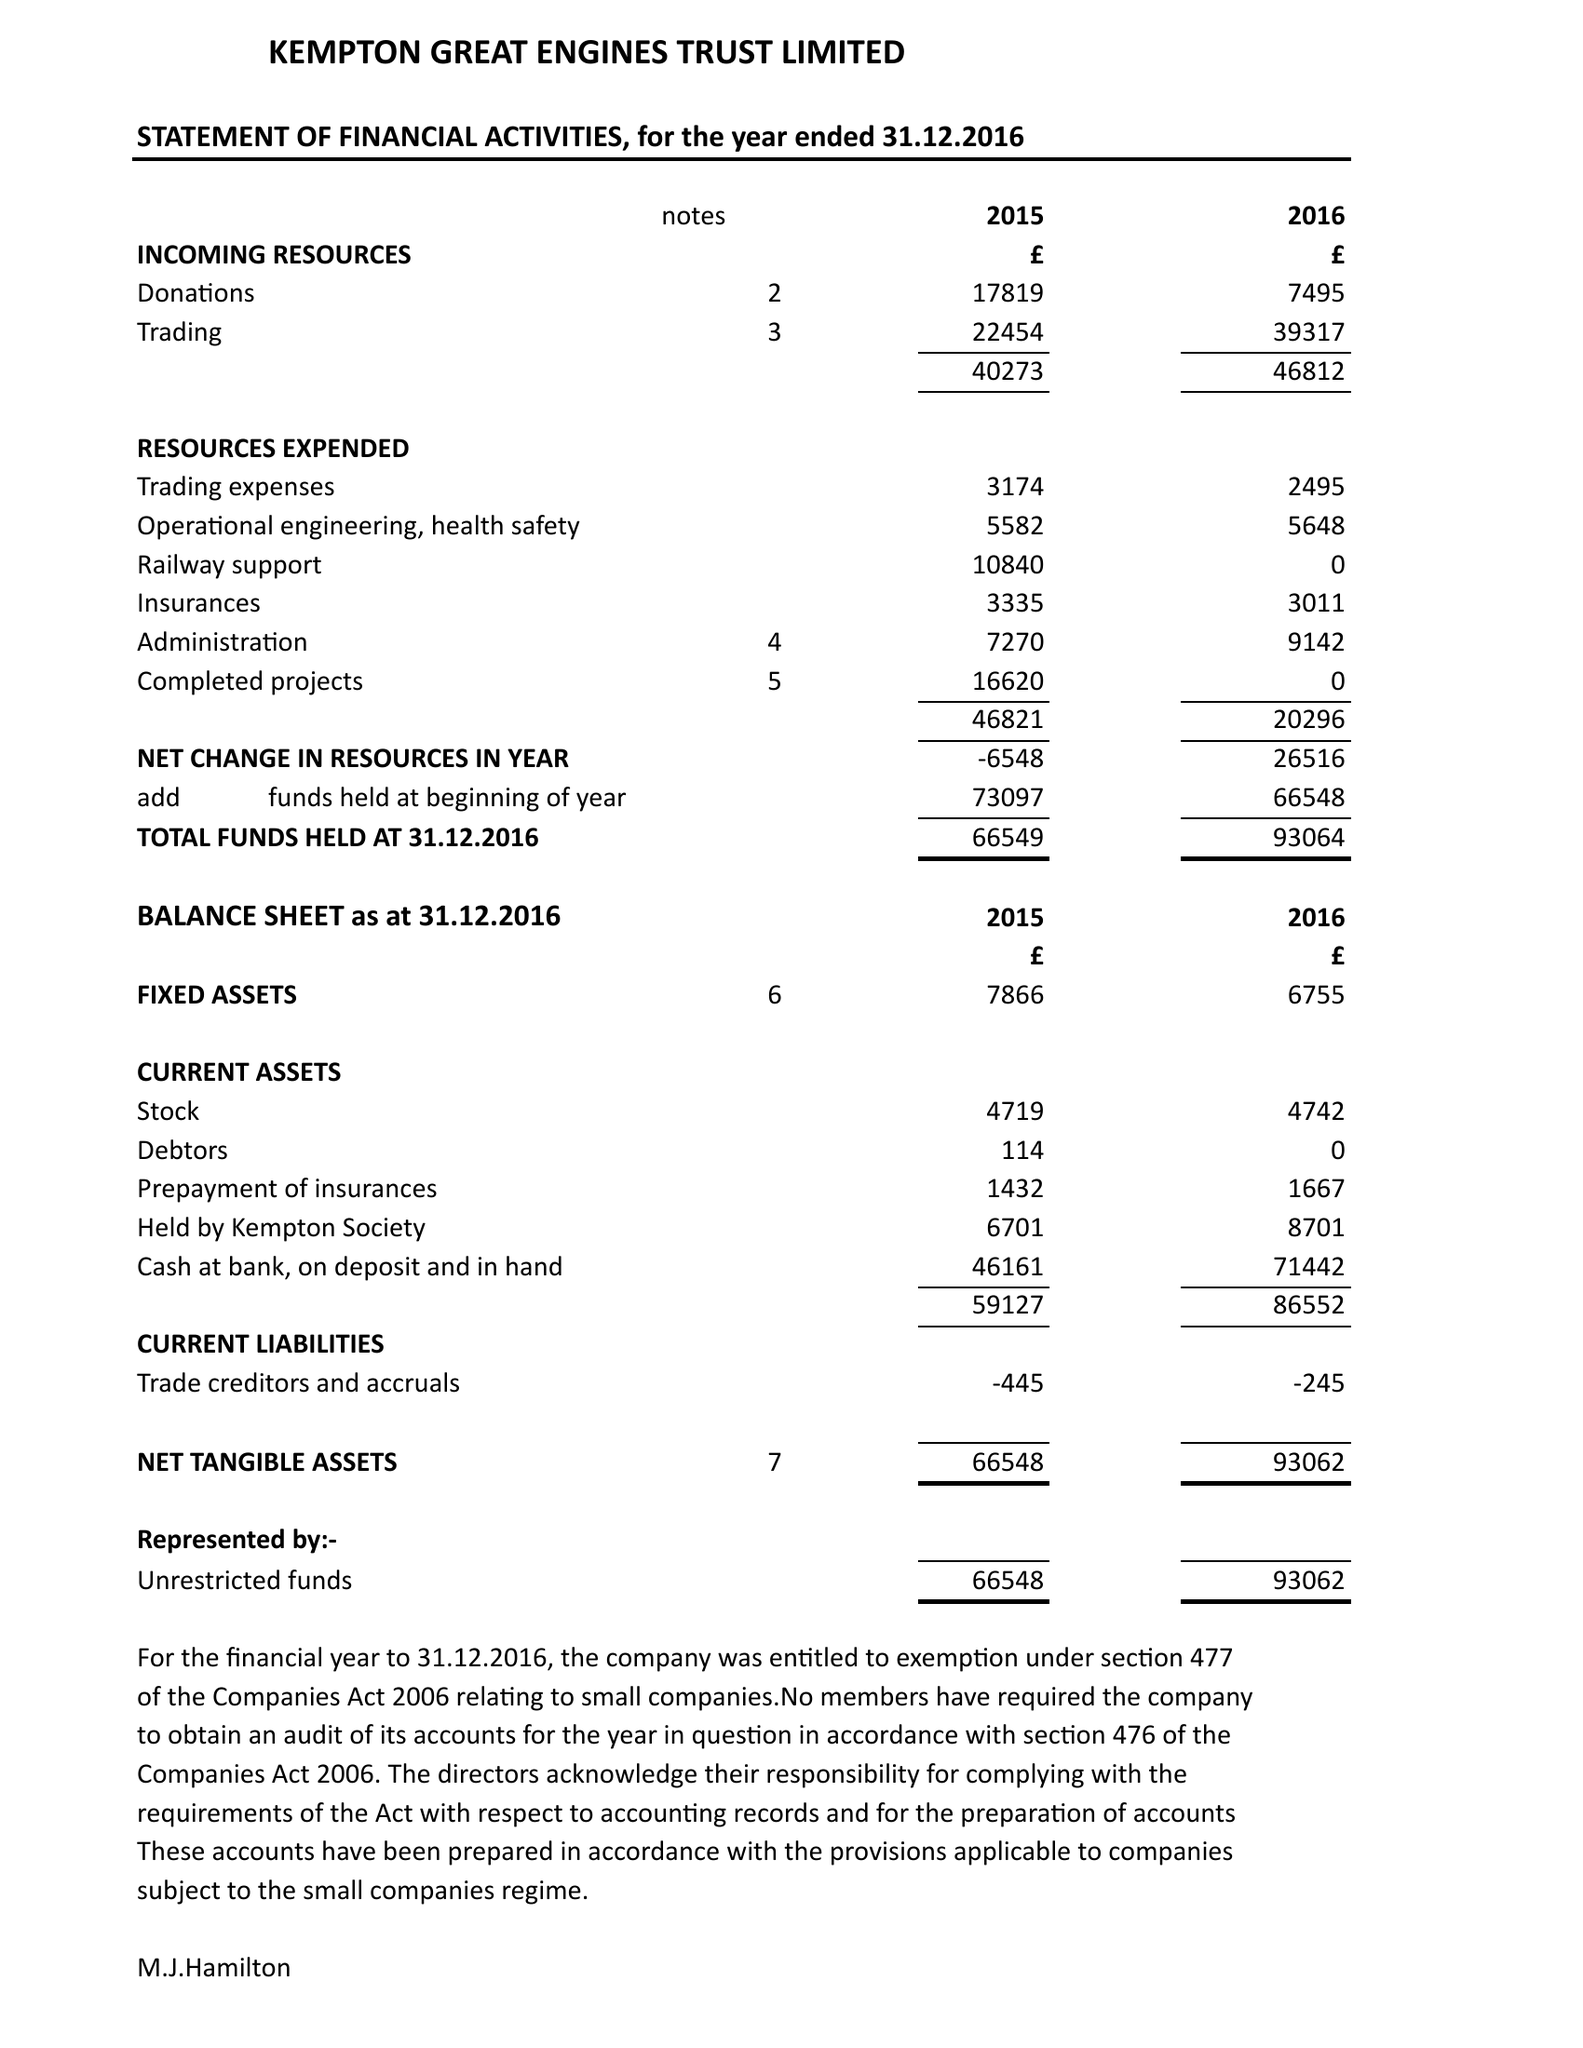What is the value for the address__postcode?
Answer the question using a single word or phrase. TW13 6XH 